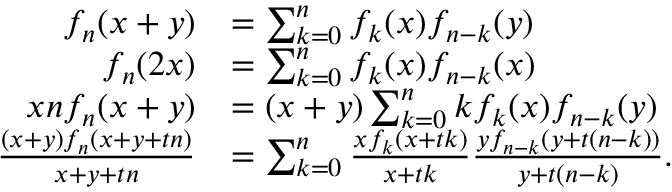<formula> <loc_0><loc_0><loc_500><loc_500>{ \begin{array} { r l } { f _ { n } ( x + y ) } & { = \sum _ { k = 0 } ^ { n } f _ { k } ( x ) f _ { n - k } ( y ) } \\ { f _ { n } ( 2 x ) } & { = \sum _ { k = 0 } ^ { n } f _ { k } ( x ) f _ { n - k } ( x ) } \\ { x n f _ { n } ( x + y ) } & { = ( x + y ) \sum _ { k = 0 } ^ { n } k f _ { k } ( x ) f _ { n - k } ( y ) } \\ { { \frac { ( x + y ) f _ { n } ( x + y + t n ) } { x + y + t n } } } & { = \sum _ { k = 0 } ^ { n } { \frac { x f _ { k } ( x + t k ) } { x + t k } } { \frac { y f _ { n - k } ( y + t ( n - k ) ) } { y + t ( n - k ) } } . } \end{array} }</formula> 